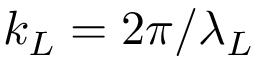<formula> <loc_0><loc_0><loc_500><loc_500>k _ { L } = 2 \pi / \lambda _ { L }</formula> 